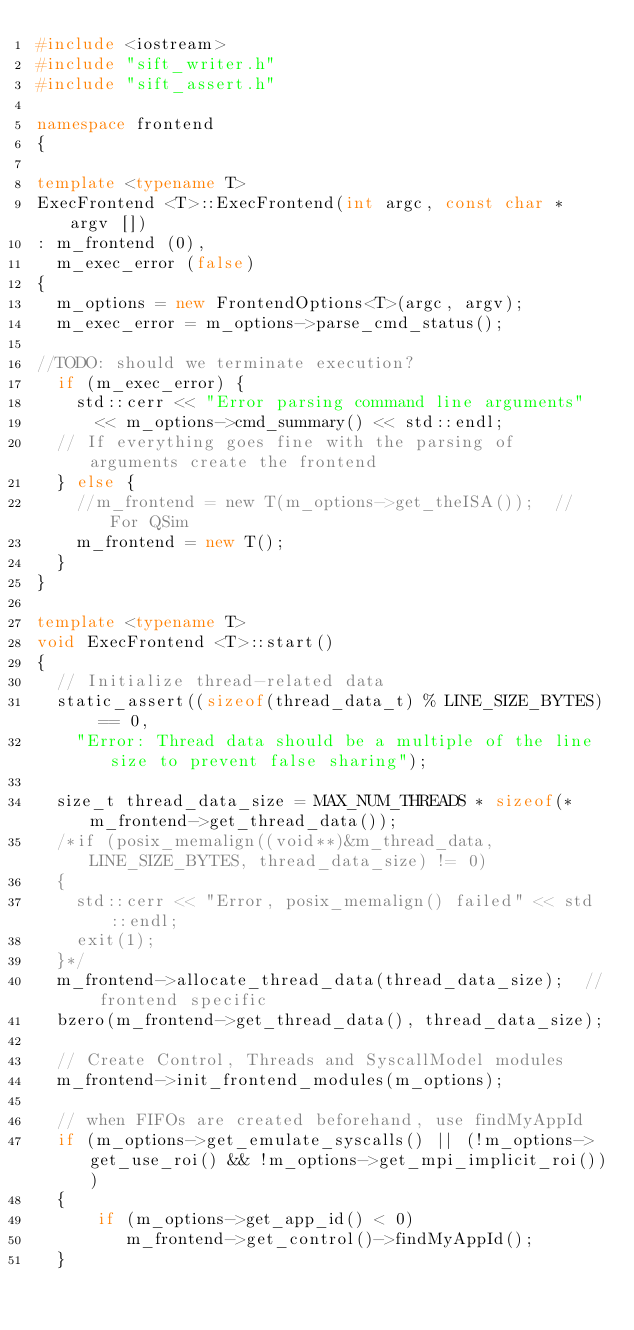<code> <loc_0><loc_0><loc_500><loc_500><_C++_>#include <iostream>
#include "sift_writer.h"
#include "sift_assert.h"

namespace frontend
{
  
template <typename T>
ExecFrontend <T>::ExecFrontend(int argc, const char * argv [])
: m_frontend (0),
  m_exec_error (false)
{
  m_options = new FrontendOptions<T>(argc, argv);
  m_exec_error = m_options->parse_cmd_status();

//TODO: should we terminate execution?
  if (m_exec_error) {
    std::cerr << "Error parsing command line arguments" 
      << m_options->cmd_summary() << std::endl;
  // If everything goes fine with the parsing of arguments create the frontend
  } else {
    //m_frontend = new T(m_options->get_theISA());  // For QSim
    m_frontend = new T();
  }
}

template <typename T>
void ExecFrontend <T>::start()
{
  // Initialize thread-related data
  static_assert((sizeof(thread_data_t) % LINE_SIZE_BYTES) == 0, 
    "Error: Thread data should be a multiple of the line size to prevent false sharing");
  
  size_t thread_data_size = MAX_NUM_THREADS * sizeof(*m_frontend->get_thread_data());
  /*if (posix_memalign((void**)&m_thread_data, LINE_SIZE_BYTES, thread_data_size) != 0)
  {
    std::cerr << "Error, posix_memalign() failed" << std::endl;
    exit(1);
  }*/
  m_frontend->allocate_thread_data(thread_data_size);  // frontend specific
  bzero(m_frontend->get_thread_data(), thread_data_size);

  // Create Control, Threads and SyscallModel modules
  m_frontend->init_frontend_modules(m_options);
  
  // when FIFOs are created beforehand, use findMyAppId
  if (m_options->get_emulate_syscalls() || (!m_options->get_use_roi() && !m_options->get_mpi_implicit_roi()))
  {
      if (m_options->get_app_id() < 0)
         m_frontend->get_control()->findMyAppId();
  }
   </code> 